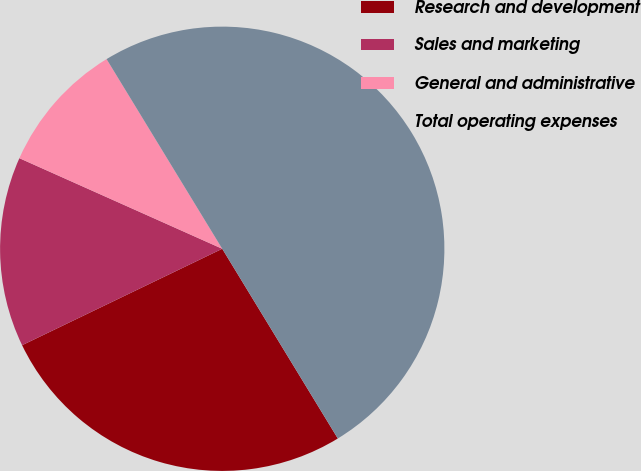Convert chart to OTSL. <chart><loc_0><loc_0><loc_500><loc_500><pie_chart><fcel>Research and development<fcel>Sales and marketing<fcel>General and administrative<fcel>Total operating expenses<nl><fcel>26.56%<fcel>13.83%<fcel>9.6%<fcel>50.0%<nl></chart> 